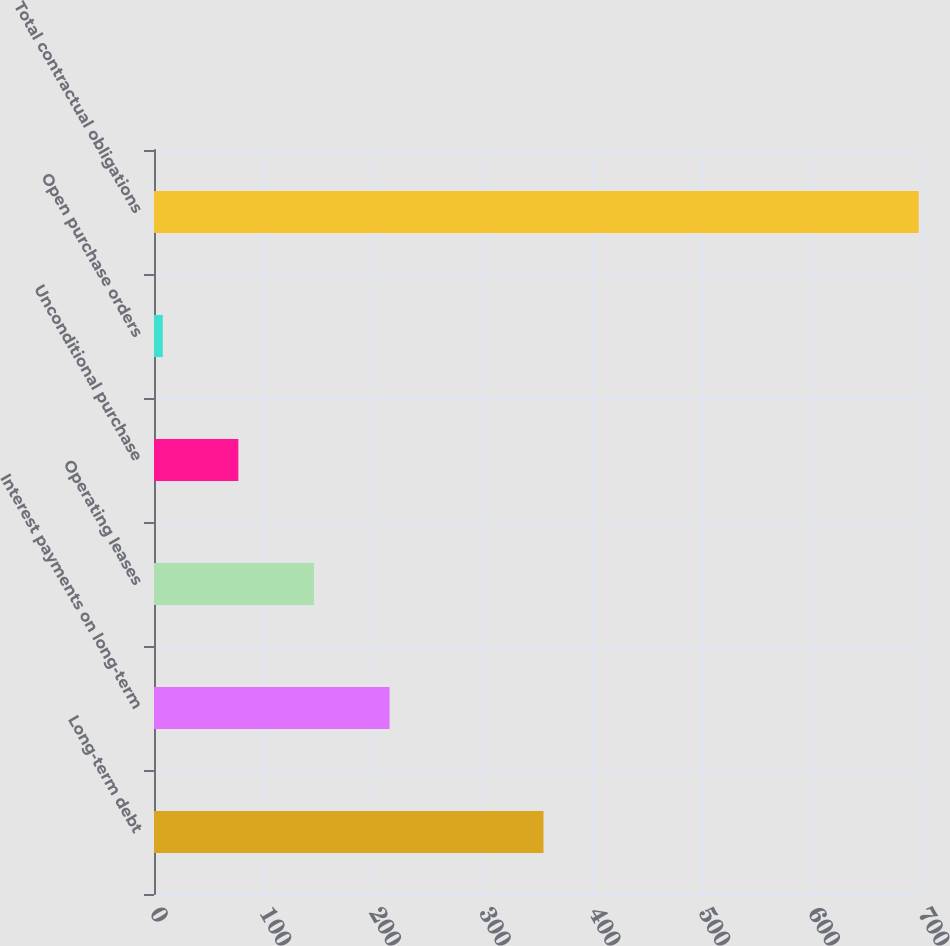Convert chart to OTSL. <chart><loc_0><loc_0><loc_500><loc_500><bar_chart><fcel>Long-term debt<fcel>Interest payments on long-term<fcel>Operating leases<fcel>Unconditional purchase<fcel>Open purchase orders<fcel>Total contractual obligations<nl><fcel>355<fcel>214.7<fcel>145.8<fcel>76.9<fcel>8<fcel>697<nl></chart> 